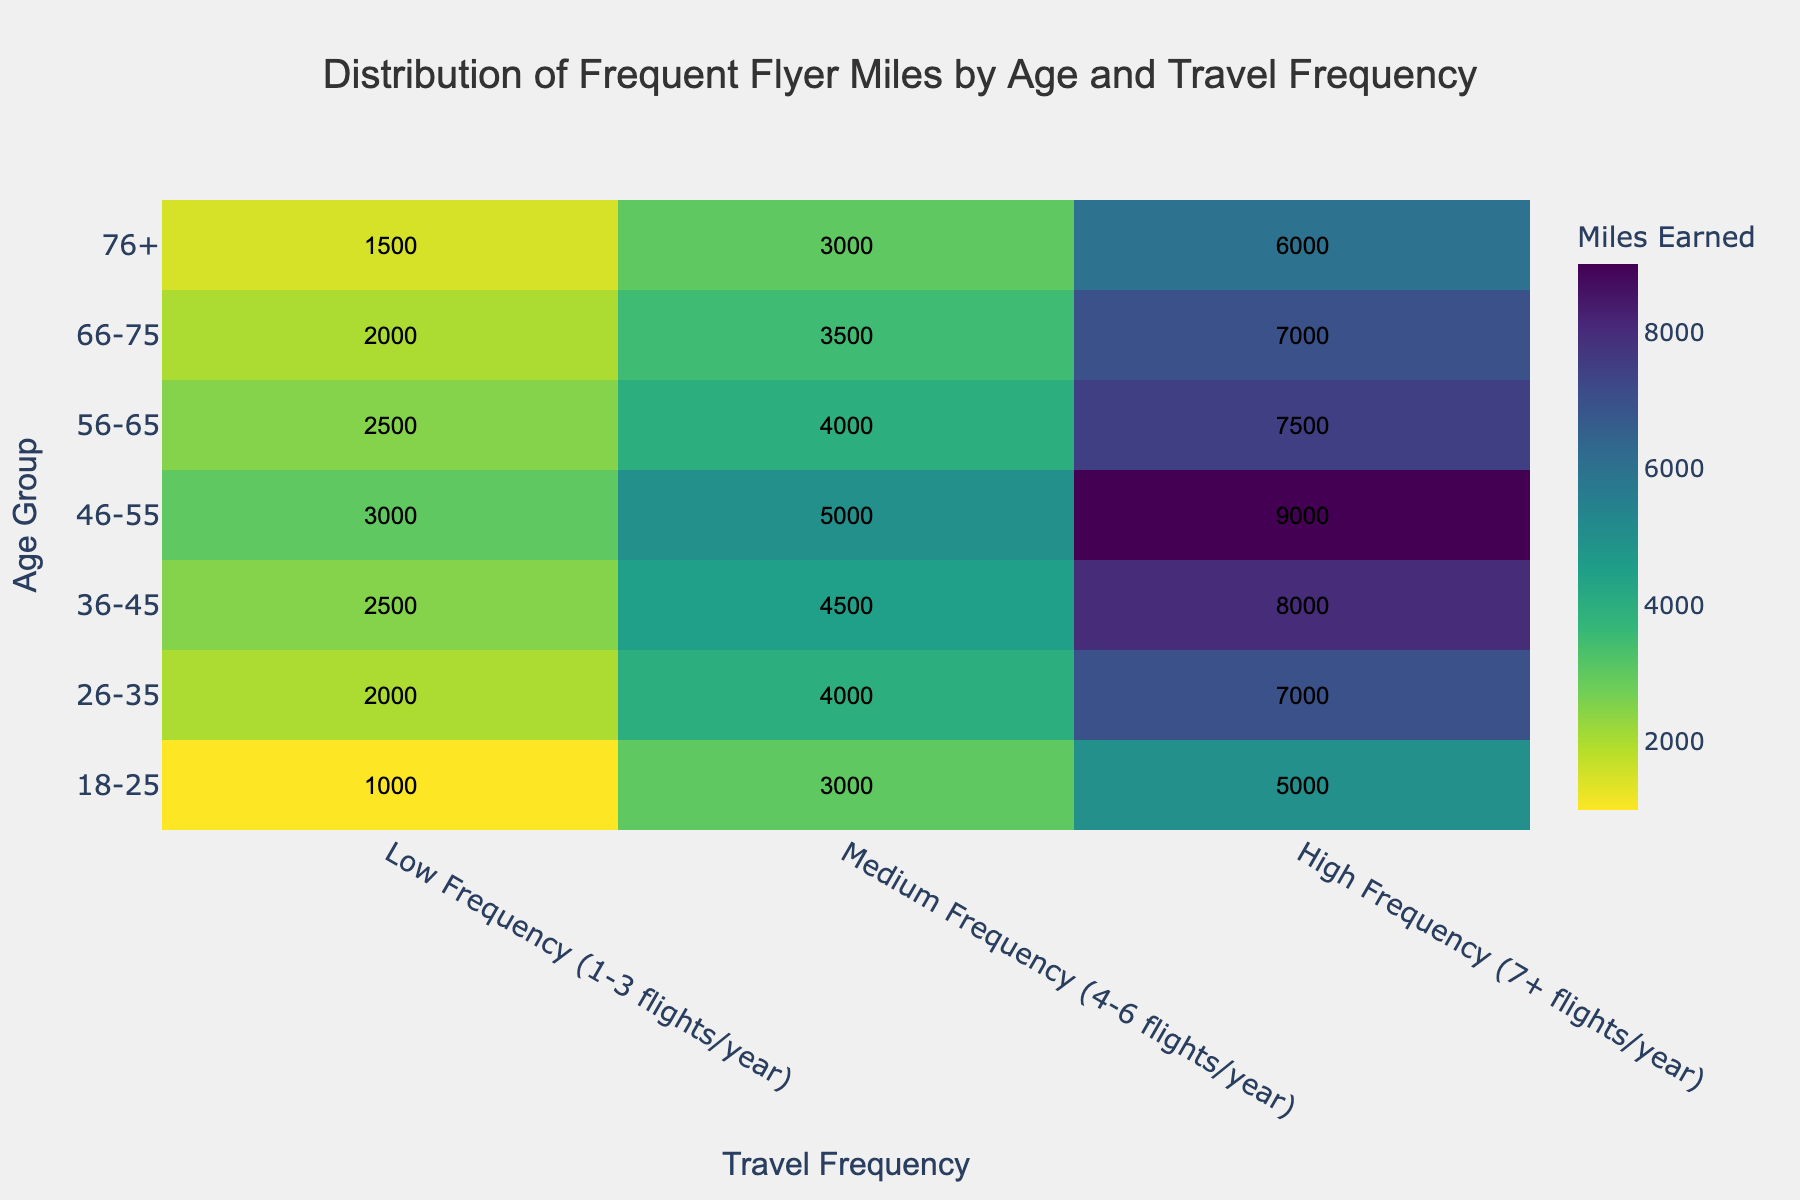what is the title of the heatmap? The title is the header text at the top center of the figure, used to describe the main content of the plot.
Answer: Distribution of Frequent Flyer Miles by Age and Travel Frequency Which age group has the highest miles earned for high-frequency travel? Look at the highest value in the 'High Frequency (7+ flights/year)' column and find the corresponding age group in the 'Age Group' row.
Answer: 46-55 How many miles do the 36-45 age group earn on average across all travel frequencies? Sum the 36-45 age group's miles for each travel frequency: 2500 (Low) + 4500 (Medium) + 8000 (High) = 15000. Divide this by the number of frequencies (3).
Answer: 5000 Which travel frequency category shows the most significant difference in miles earned between the youngest and oldest age groups? You need to compute the difference for each travel frequency: For Low: 1000 - 1500 = -500. For Medium: 3000 - 3000 = 0. For High: 5000 - 6000 = -1000. The highest absolute value gives the answer.
Answer: High Frequency (7+ flights/year) What is the color that represents the highest miles earned? Refer to the color bar on the heatmap which corresponds to the highest number of miles (9000).
Answer: Dark yellow Which age group earns more miles in medium-frequency travel, 18-25 or 56-65? Compare the values in the 'Medium Frequency' column for both age groups: 18-25 (3000), 56-65 (4000).
Answer: 56-65 How do the miles earned by the 46-55 age group in low-frequency compare to high-frequency? Compare the value for 46-55 in Low Frequency (3000 miles) to High Frequency (9000 miles). Subtract Low from High: 9000 - 3000 = 6000.
Answer: 6000 more miles Which age group sees the least variation in miles earned across different travel frequencies? Compare the differences in miles earned among the categories for each age group. Look at the smallest range.
Answer: 18-25 What is the total number of miles earned by all age groups in low-frequency travel? Sum the columns for Low Frequency across all age groups: 1000 (18-25) + 2000 (26-35) + 2500 (36-45) + 3000 (46-55) + 2500 (56-65) + 2000 (66-75) + 1500 (76+).
Answer: 14500 miles Do older age groups generally earn more or fewer frequent flyer miles than younger age groups in high-frequency travel? Observe the trend in the 'High Frequency (7+ flights/year)' column from youngest to oldest age groups.
Answer: More 